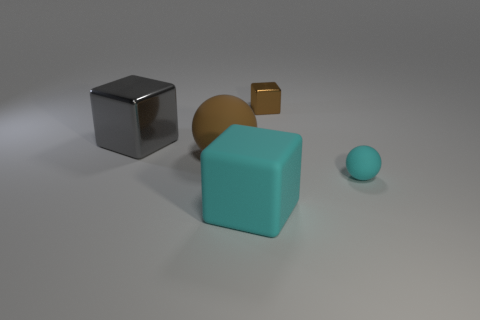There is a small object that is the same material as the big cyan object; what is its color?
Your answer should be compact. Cyan. Is the number of big red metallic cylinders less than the number of brown objects?
Provide a succinct answer. Yes. There is a large block to the left of the rubber ball left of the brown object right of the brown sphere; what is its material?
Your answer should be compact. Metal. What material is the tiny brown thing?
Offer a very short reply. Metal. There is a small object that is in front of the tiny brown metal object; is it the same color as the matte ball that is on the left side of the small metallic thing?
Provide a short and direct response. No. Is the number of small blocks greater than the number of purple spheres?
Provide a succinct answer. Yes. What number of rubber things are the same color as the tiny matte ball?
Your answer should be compact. 1. There is another large thing that is the same shape as the large cyan rubber object; what is its color?
Offer a terse response. Gray. The big object that is behind the cyan block and on the right side of the gray metallic object is made of what material?
Make the answer very short. Rubber. Is the material of the big block on the right side of the gray metal thing the same as the tiny thing in front of the big shiny object?
Provide a short and direct response. Yes. 